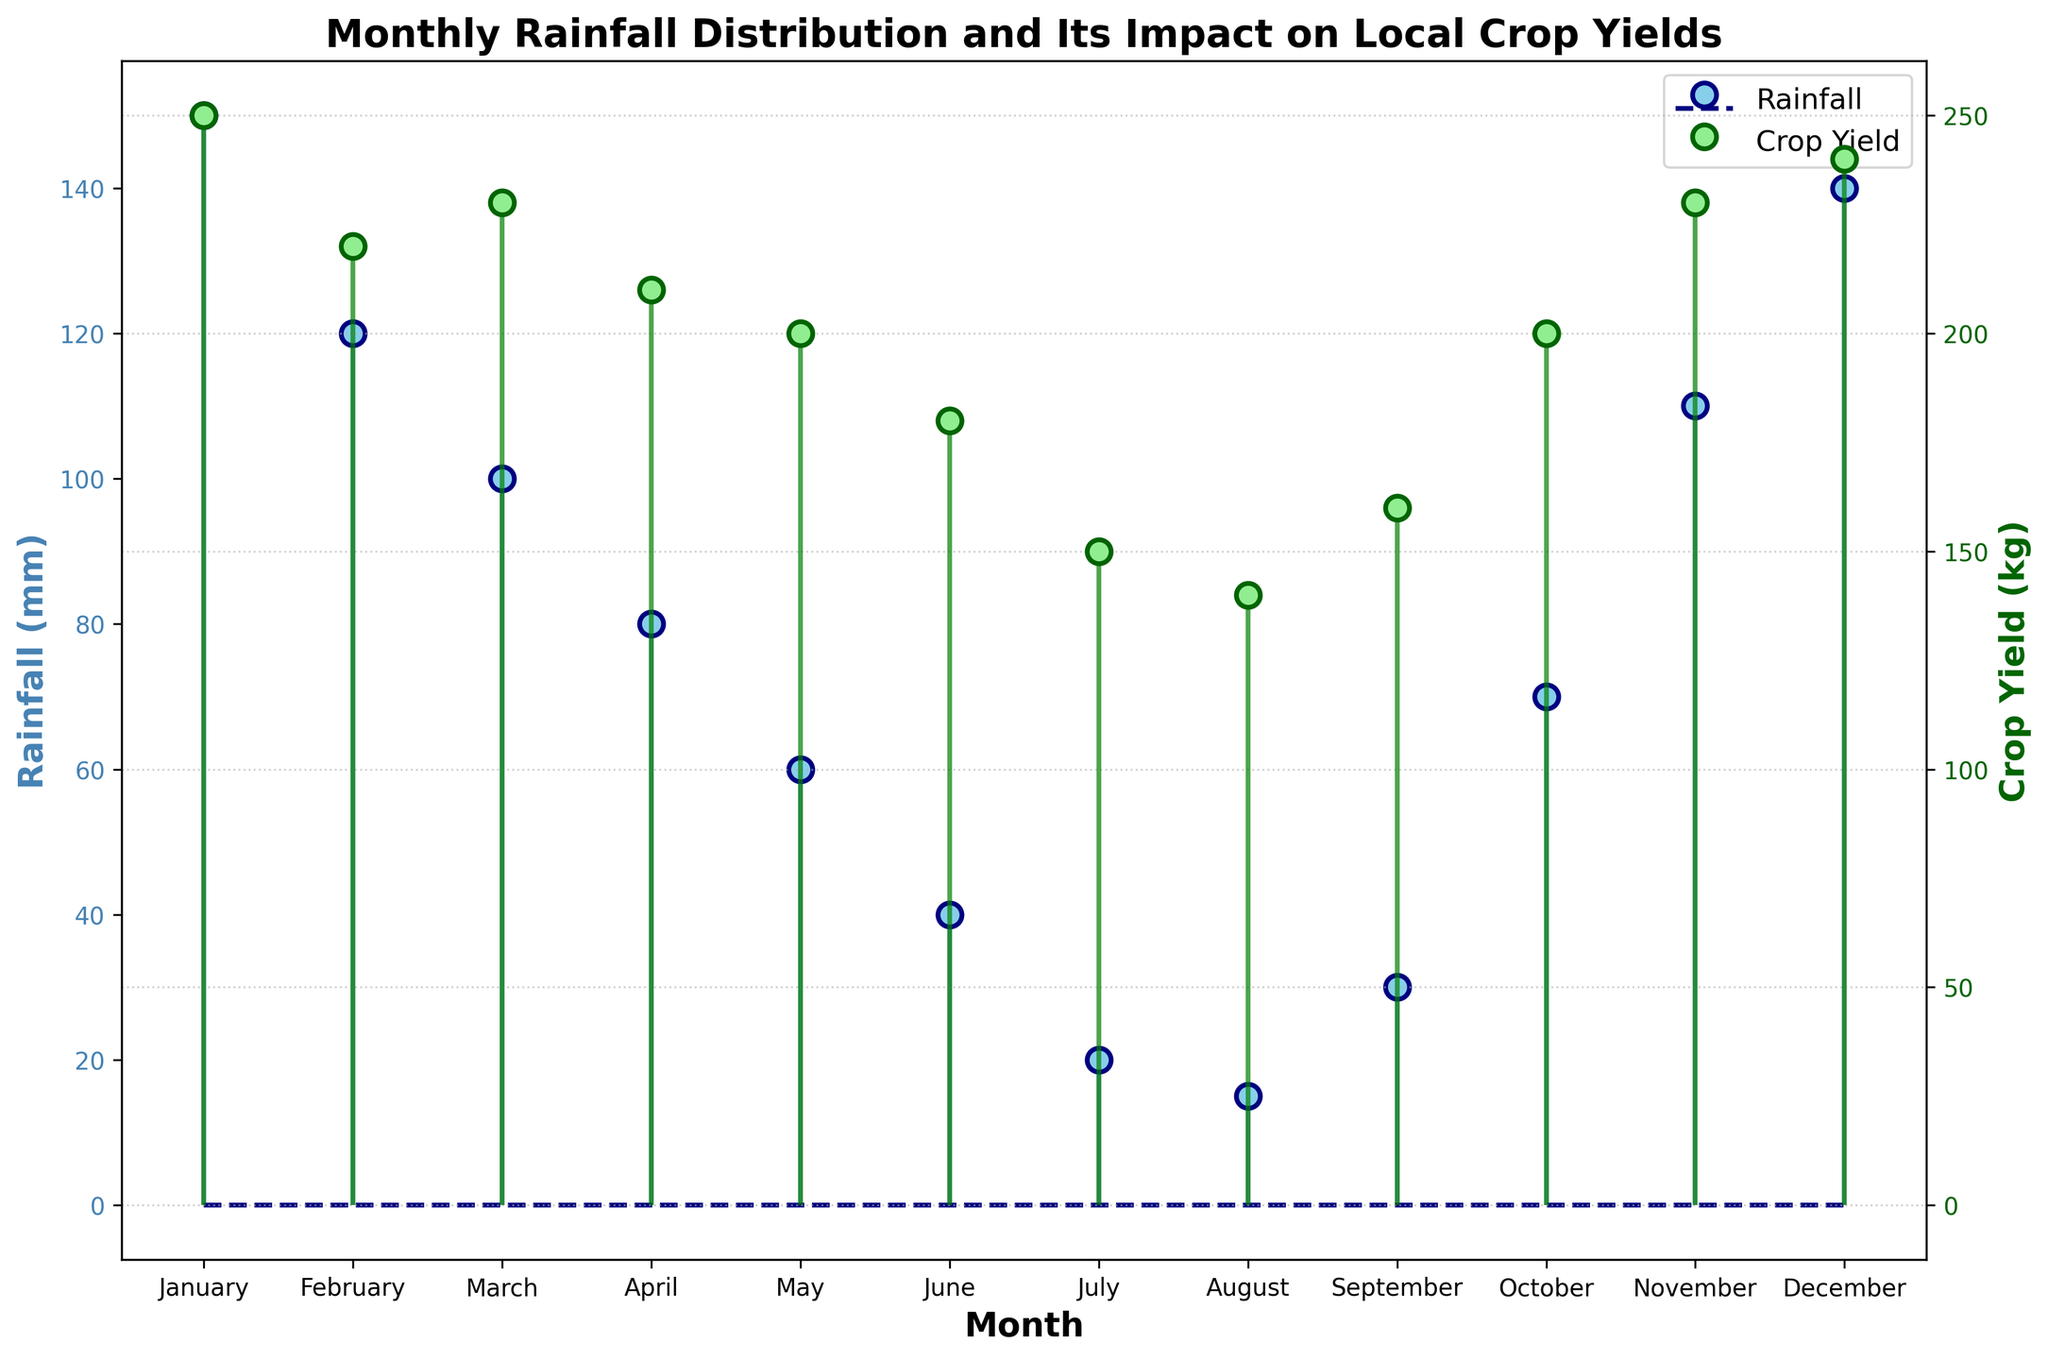What is the title of the figure? The title of a figure is usually located at the top center and it gives an overview of the depicted data.
Answer: Monthly Rainfall Distribution and Its Impact on Local Crop Yields In which month does the lowest rainfall occur? To find the month with the lowest rainfall, look at the stem plot where the rainfall is represented by blue lines and markers, and identify the lowest point on the y-axis labeled "Rainfall (mm)."
Answer: August What is the average crop yield in the months of June, July, and August? Sum the crop yields of June, July, and August (180 + 150 + 140 = 470) and divide by the number of months (3).
Answer: 156.67 kg How does the crop yield in December compare to September? Compare the green markers/dots for December and September on the crop yield axis to see which is higher.
Answer: December has higher crop yield Which month has the highest crop yield, and what is that yield? Look for the highest green marker on the y-axis labeled "Crop Yield (kg)" to identify the month and the corresponding value.
Answer: January, 250 kg Does higher rainfall always lead to higher crop yield within a single month? Check if the months with higher rainfall markers (blue) always align with higher crop yield markers (green).
Answer: No How many months experienced less than 100 mm of rainfall? Count the blue markers that are below the 100 mm line on the y-axis labeled "Rainfall (mm)."
Answer: 6 months (April, May, June, July, August, September) What is the difference in rainfall between the wettest and driest months? Identify the rainfall in January (wettest month, 150 mm), and August (driest month, 15 mm), then subtract August's rainfall from January's.
Answer: 135 mm Which month has the same crop yield as April? Find April's crop yield value (210 kg) and identify any other month with the same green marker value.
Answer: October 